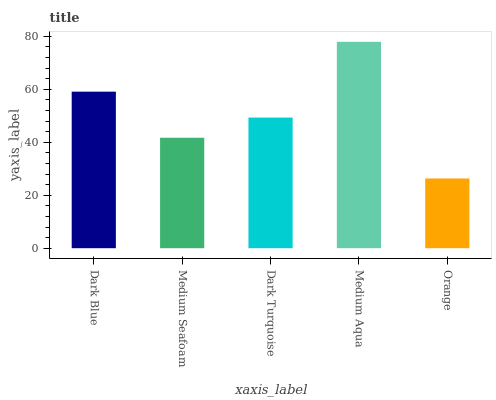Is Orange the minimum?
Answer yes or no. Yes. Is Medium Aqua the maximum?
Answer yes or no. Yes. Is Medium Seafoam the minimum?
Answer yes or no. No. Is Medium Seafoam the maximum?
Answer yes or no. No. Is Dark Blue greater than Medium Seafoam?
Answer yes or no. Yes. Is Medium Seafoam less than Dark Blue?
Answer yes or no. Yes. Is Medium Seafoam greater than Dark Blue?
Answer yes or no. No. Is Dark Blue less than Medium Seafoam?
Answer yes or no. No. Is Dark Turquoise the high median?
Answer yes or no. Yes. Is Dark Turquoise the low median?
Answer yes or no. Yes. Is Orange the high median?
Answer yes or no. No. Is Medium Aqua the low median?
Answer yes or no. No. 